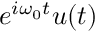Convert formula to latex. <formula><loc_0><loc_0><loc_500><loc_500>e ^ { i \omega _ { 0 } t } u ( t )</formula> 